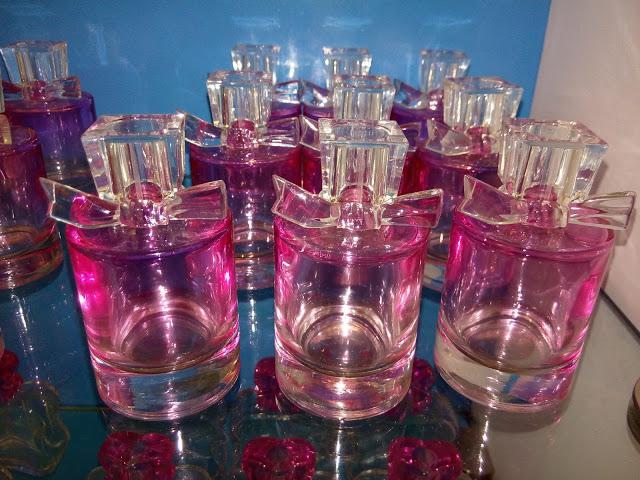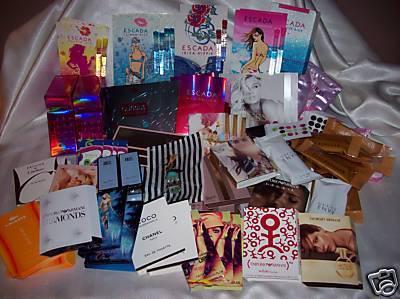The first image is the image on the left, the second image is the image on the right. Analyze the images presented: Is the assertion "The collection of fragrance bottles on the right includes a squat round black bottle with a pink tube and bulb attached." valid? Answer yes or no. No. The first image is the image on the left, the second image is the image on the right. Assess this claim about the two images: "The image on the left boasts less than ten items.". Correct or not? Answer yes or no. Yes. 